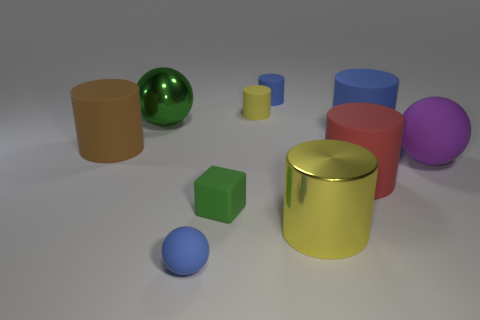There is a cube that is the same color as the metallic ball; what material is it?
Provide a succinct answer. Rubber. There is a big cylinder that is in front of the green block; what is its material?
Offer a terse response. Metal. There is a large brown thing that is the same shape as the big blue matte thing; what material is it?
Offer a terse response. Rubber. Are there any small green cubes behind the blue rubber thing that is left of the yellow rubber cylinder?
Provide a short and direct response. Yes. Is the big green object the same shape as the purple rubber thing?
Keep it short and to the point. Yes. The large blue object that is made of the same material as the brown thing is what shape?
Offer a very short reply. Cylinder. Do the blue thing that is on the left side of the green matte object and the yellow object that is behind the green rubber object have the same size?
Give a very brief answer. Yes. Are there more objects behind the large blue matte thing than large brown things that are in front of the small green matte block?
Offer a very short reply. Yes. What number of other things are the same color as the big matte ball?
Give a very brief answer. 0. There is a large metal cylinder; does it have the same color as the rubber thing on the left side of the large green metal sphere?
Make the answer very short. No. 